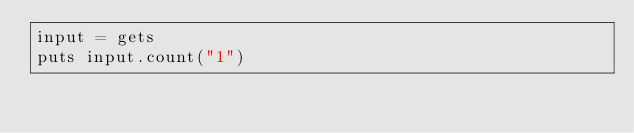Convert code to text. <code><loc_0><loc_0><loc_500><loc_500><_Ruby_>input = gets
puts input.count("1")</code> 